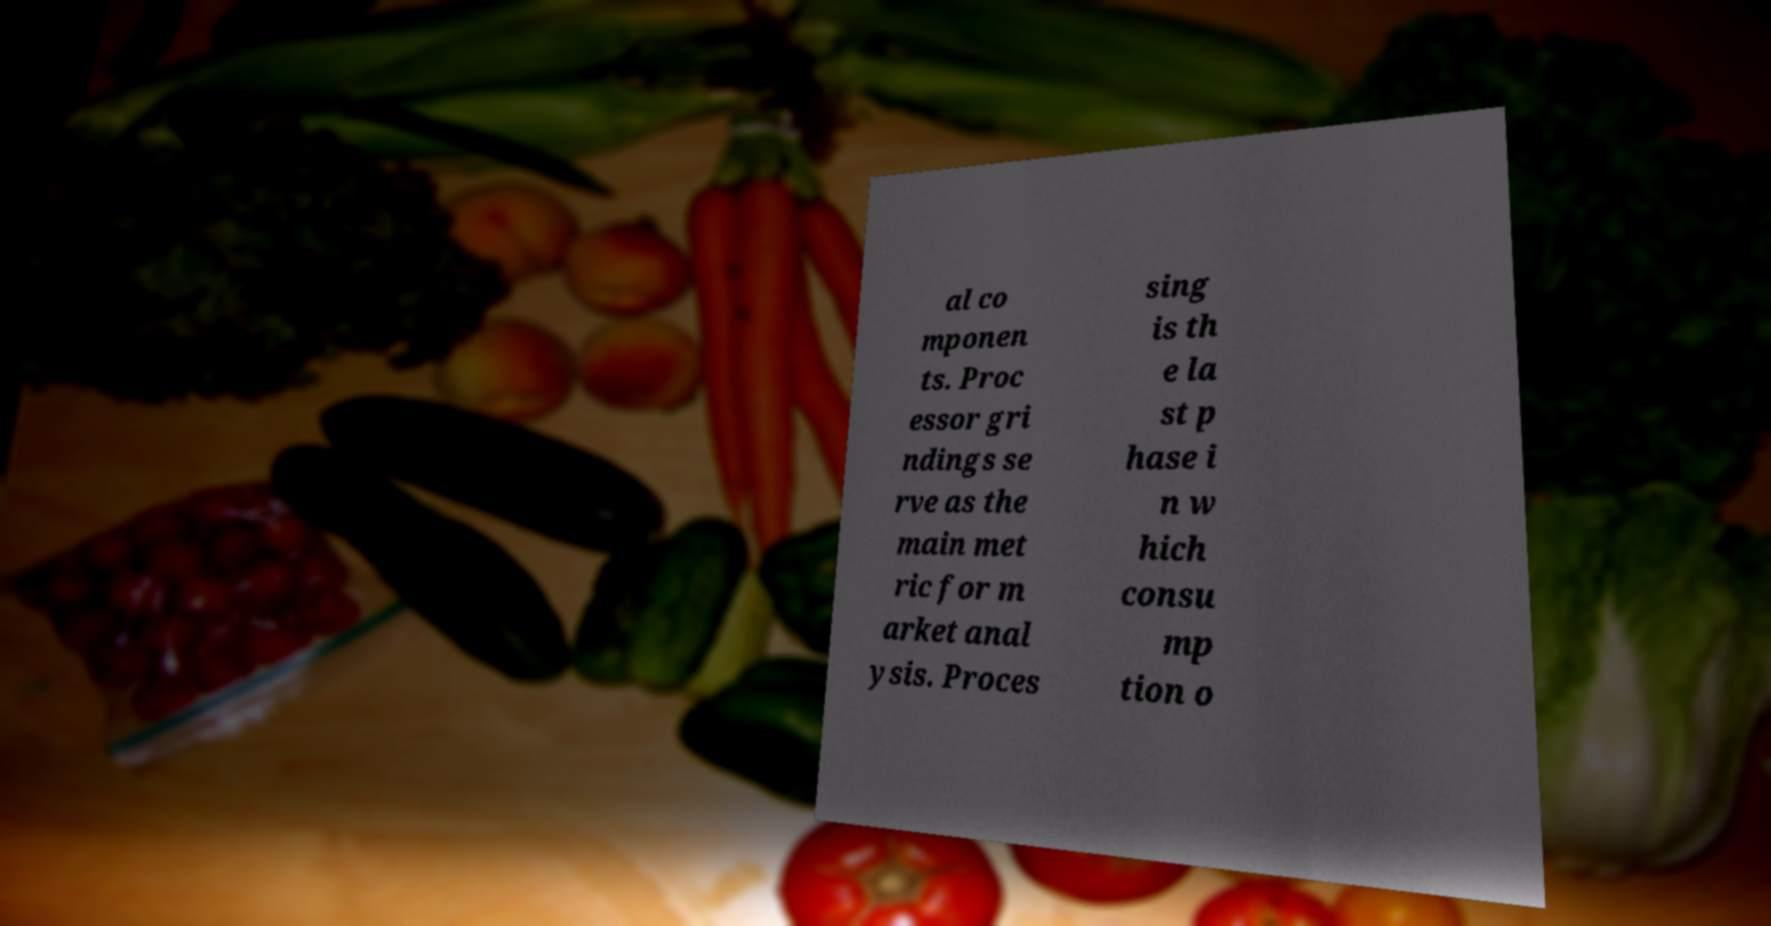Please read and relay the text visible in this image. What does it say? al co mponen ts. Proc essor gri ndings se rve as the main met ric for m arket anal ysis. Proces sing is th e la st p hase i n w hich consu mp tion o 